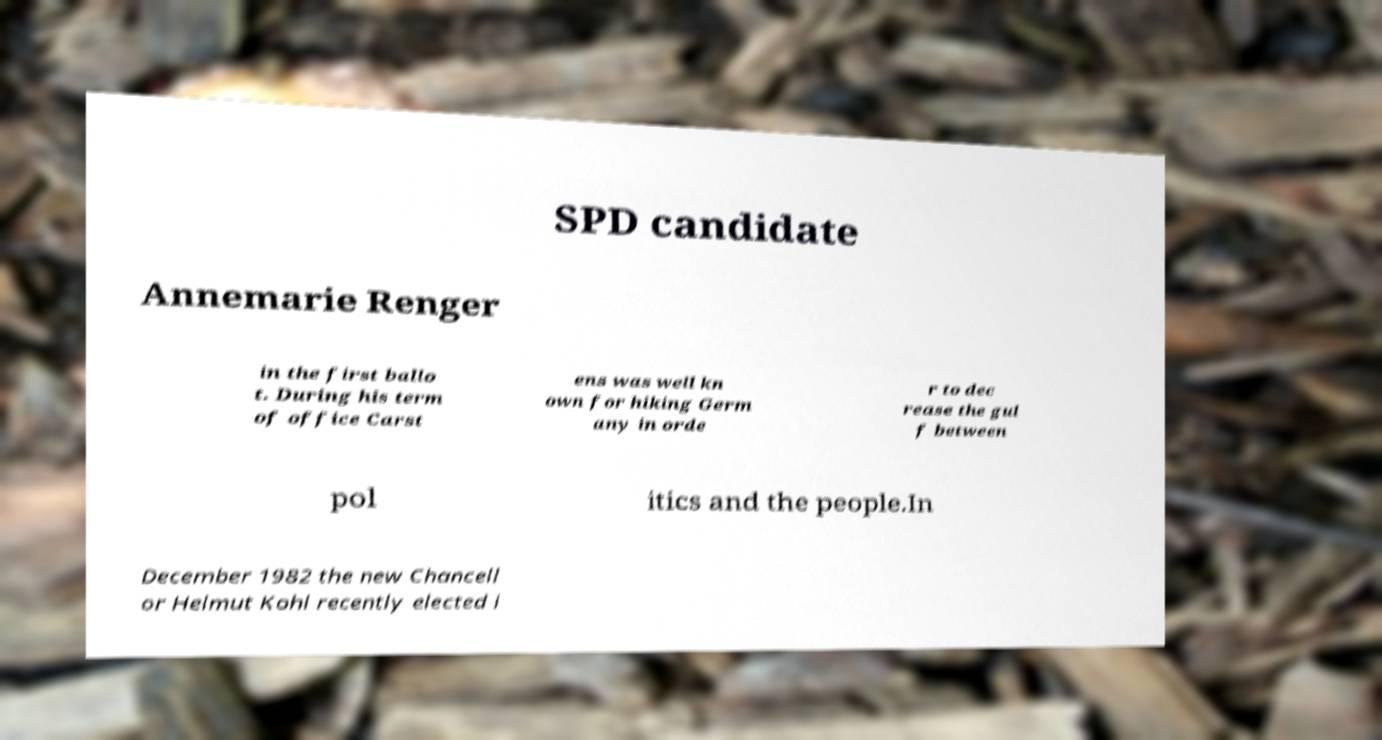Can you accurately transcribe the text from the provided image for me? SPD candidate Annemarie Renger in the first ballo t. During his term of office Carst ens was well kn own for hiking Germ any in orde r to dec rease the gul f between pol itics and the people.In December 1982 the new Chancell or Helmut Kohl recently elected i 